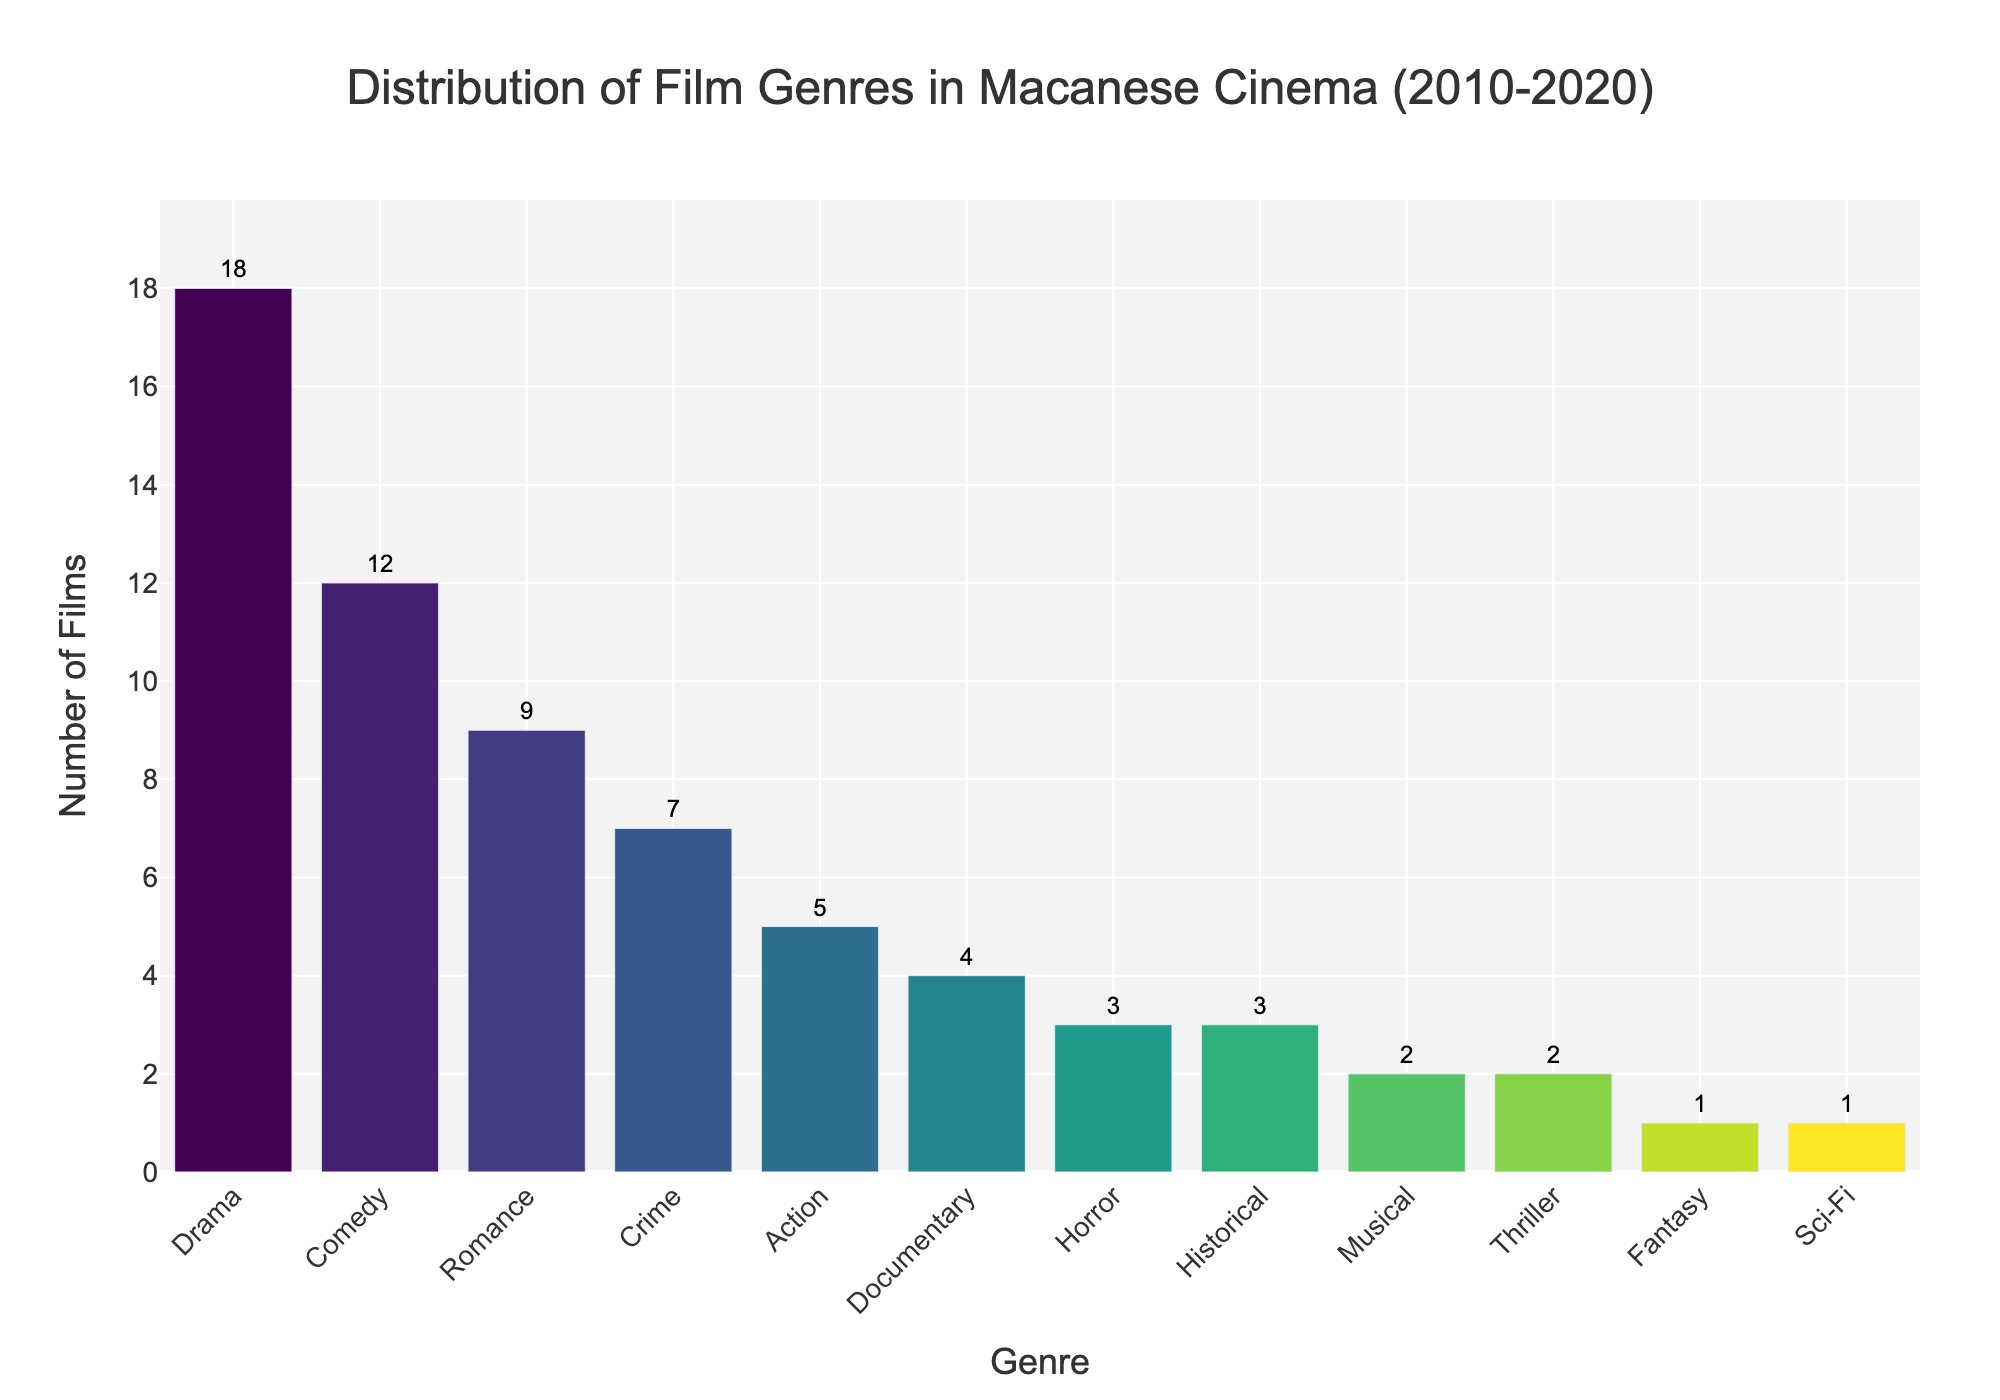What's the most produced genre in Macanese cinema between 2010-2020? The tallest bar represents the genre with the most films. Here, the "Drama" genre has the highest bar with 18 films.
Answer: Drama How many genres have more than 10 films produced? Counting the bars that have heights above the 10-unit line, we see that only "Drama" and "Comedy" have more than 10 films each.
Answer: 2 Which genres have the same number of films produced? By visually examining the bar heights, "Horror" and "Historical" both have bars representing 3 films each, and "Musical" and "Thriller" both have bars representing 2 films each.
Answer: Horror and Historical; Musical and Thriller What is the difference in the number of films between the most produced genre and the least produced genre? The most produced genre is "Drama" with 18 films, and the least produced genres are "Fantasy" and "Sci-Fi" with 1 film each. The difference is 18 - 1.
Answer: 17 How many more Comedy films are there compared to Horror films? The height of the "Comedy" bar is 12 films, and the height of the "Horror" bar is 3 films. The difference is 12 - 3 films.
Answer: 9 What is the total number of films produced for the top 3 genres combined? The top three genres based on bar heights are "Drama" (18 films), "Comedy" (12 films), and "Romance" (9 films). Summing these, 18 + 12 + 9 = 39 films.
Answer: 39 What percentage of the total films produced are Action films? Summing the bars' values gives the total number of films as 67. The "Action" genre has 5 films. The percentage is (5/67) * 100 which is approximately 7.46%.
Answer: Approximately 7.46% If Musical and Thriller genres were combined, how many films would they total? Each of these genres has 2 films. Adding these gives 2 + 2 = 4 films.
Answer: 4 Which genre has half the number of Comedy films? The "Comedy" genre has 12 films. Half of this is 6, and the closest genre is "Crime" with 7 films (but 6 is not directly present). It implies none exactly.
Answer: None 